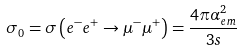<formula> <loc_0><loc_0><loc_500><loc_500>\sigma _ { 0 } = \sigma \left ( e ^ { - } e ^ { + } \rightarrow \mu ^ { - } \mu ^ { + } \right ) = \frac { 4 \pi \alpha _ { e m } ^ { 2 } } { 3 s }</formula> 